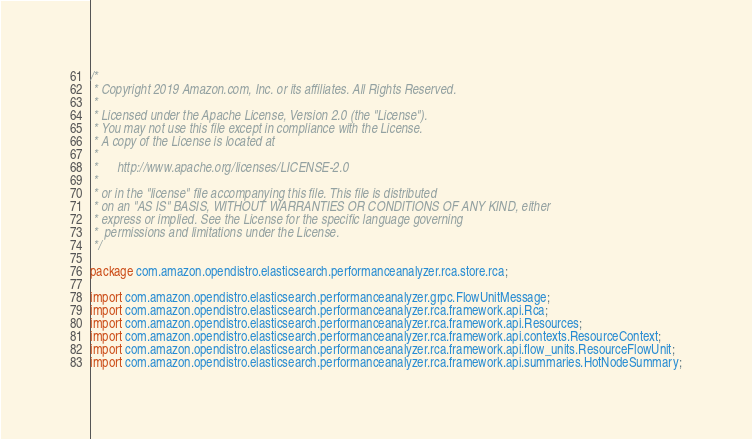<code> <loc_0><loc_0><loc_500><loc_500><_Java_>/*
 * Copyright 2019 Amazon.com, Inc. or its affiliates. All Rights Reserved.
 *
 * Licensed under the Apache License, Version 2.0 (the "License").
 * You may not use this file except in compliance with the License.
 * A copy of the License is located at
 *
 *      http://www.apache.org/licenses/LICENSE-2.0
 *
 * or in the "license" file accompanying this file. This file is distributed
 * on an "AS IS" BASIS, WITHOUT WARRANTIES OR CONDITIONS OF ANY KIND, either
 * express or implied. See the License for the specific language governing
 *  permissions and limitations under the License.
 */

package com.amazon.opendistro.elasticsearch.performanceanalyzer.rca.store.rca;

import com.amazon.opendistro.elasticsearch.performanceanalyzer.grpc.FlowUnitMessage;
import com.amazon.opendistro.elasticsearch.performanceanalyzer.rca.framework.api.Rca;
import com.amazon.opendistro.elasticsearch.performanceanalyzer.rca.framework.api.Resources;
import com.amazon.opendistro.elasticsearch.performanceanalyzer.rca.framework.api.contexts.ResourceContext;
import com.amazon.opendistro.elasticsearch.performanceanalyzer.rca.framework.api.flow_units.ResourceFlowUnit;
import com.amazon.opendistro.elasticsearch.performanceanalyzer.rca.framework.api.summaries.HotNodeSummary;</code> 